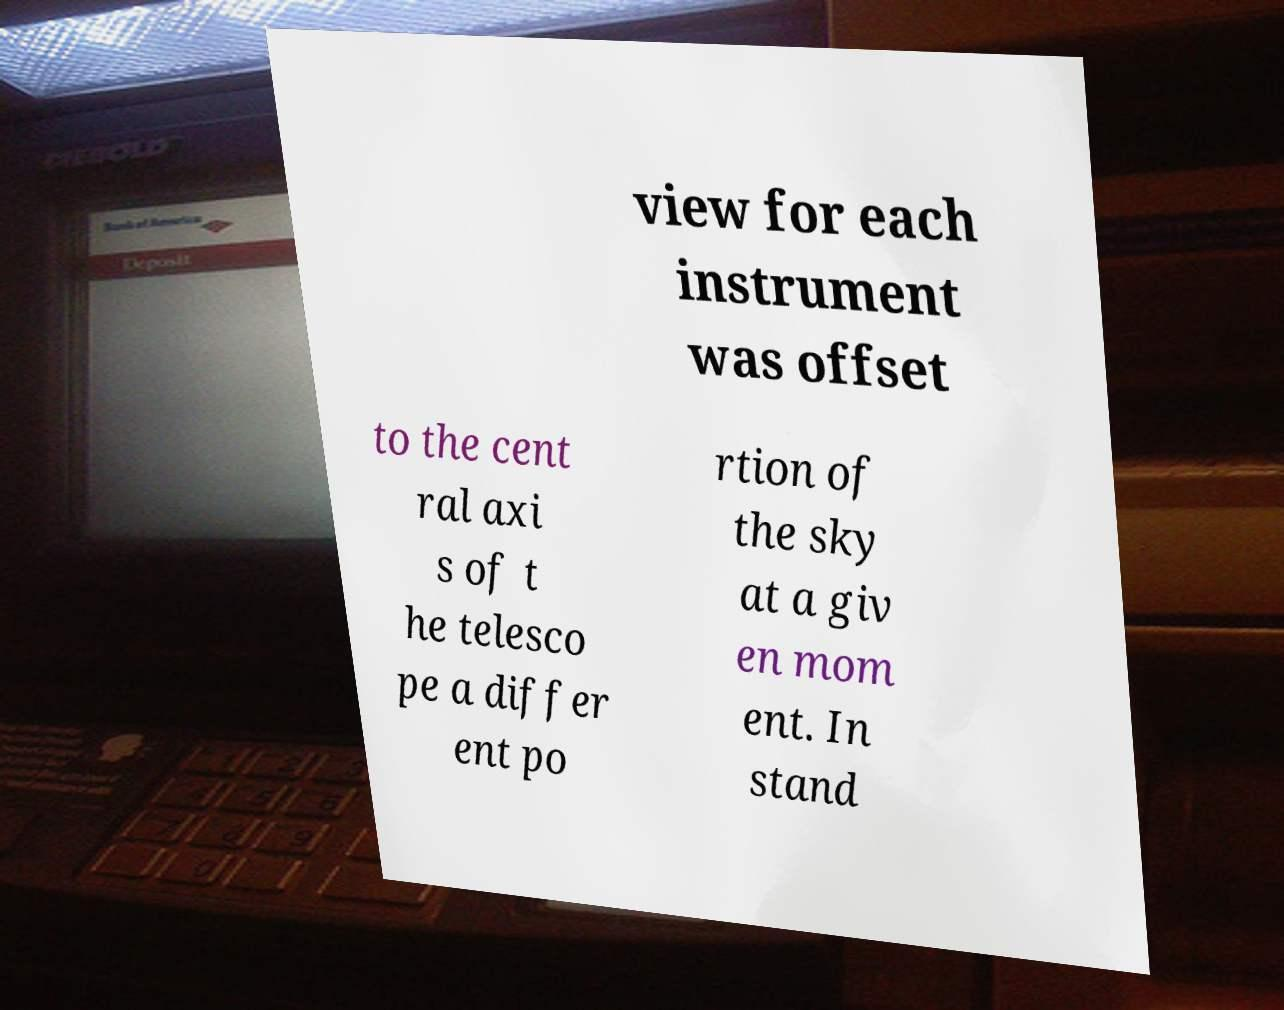Could you extract and type out the text from this image? view for each instrument was offset to the cent ral axi s of t he telesco pe a differ ent po rtion of the sky at a giv en mom ent. In stand 